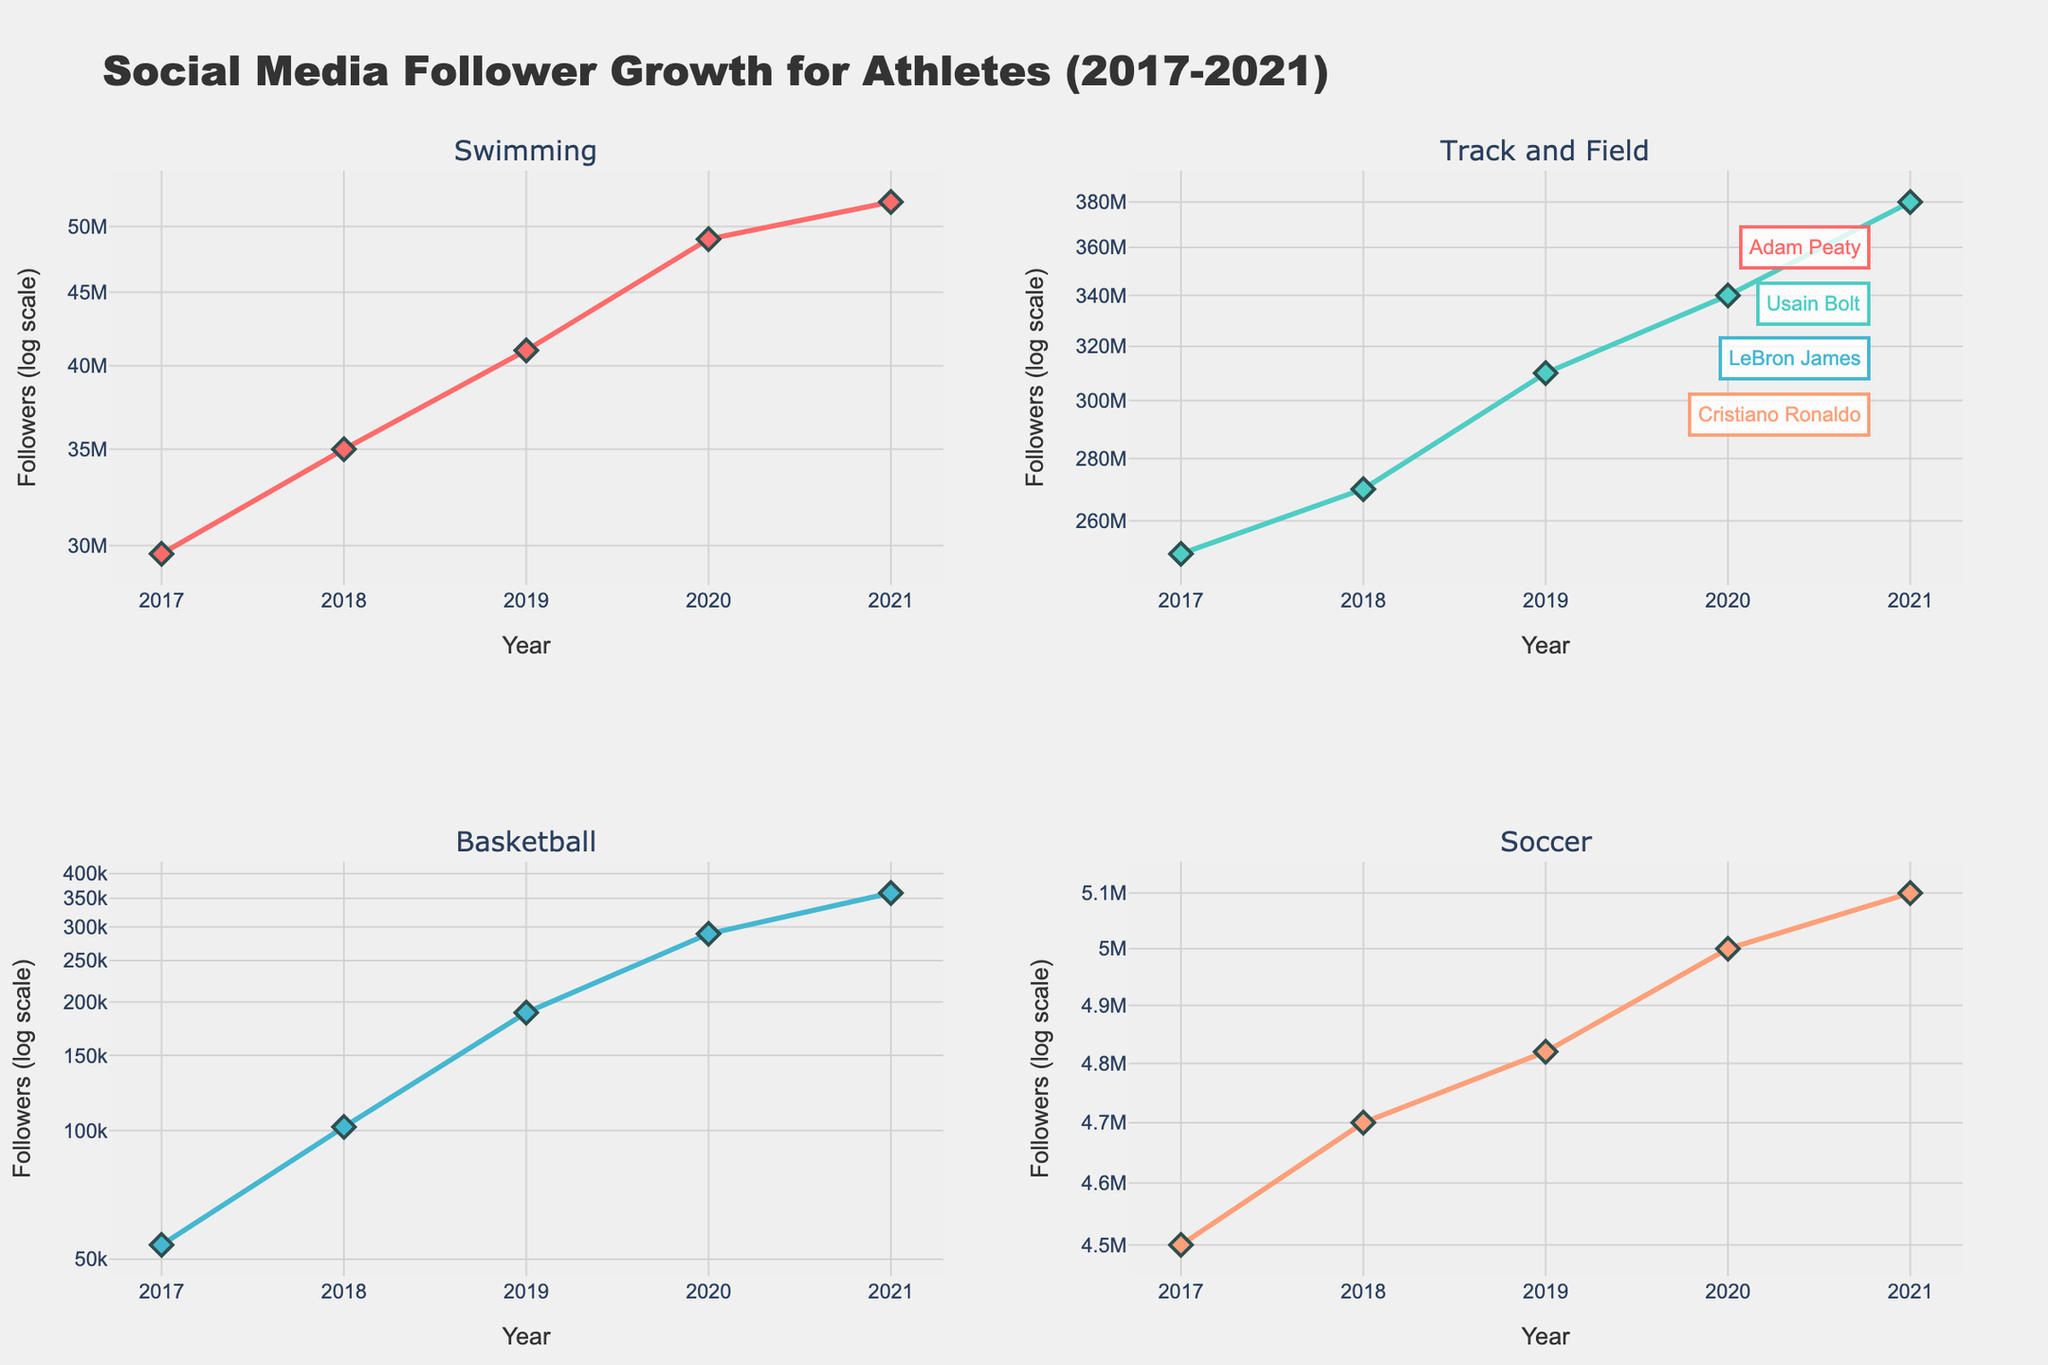What's the title of the figure? The title of the figure is displayed at the top and reads "Social Media Follower Growth for Athletes (2017-2021)."
Answer: Social Media Follower Growth for Athletes (2017-2021) How are the subplots organized in relation to the sporting events? The subplots are organized in a 2x2 grid, each representing a different sporting event: Swimming, Track and Field, Basketball, and Soccer.
Answer: 2x2 grid Which athlete had the highest number of followers in 2021? From the subplot with the highest number of followers, we can see Cristiano Ronaldo in Soccer had the most followers in 2021, at 380,000,000.
Answer: Cristiano Ronaldo Which subplot has the steepest growth in followers from 2017 to 2021? By comparing the slopes of the lines in each subplot, the subplot for Soccer (Cristiano Ronaldo) shows the steepest growth in followers between 2017 and 2021.
Answer: Soccer (Cristiano Ronaldo) Compare the follower growth of Adam Peaty and Usain Bolt between 2018 and 2019. Who had a higher percentage increase? Adam Peaty's followers increased from 102,000 to 189,000, a percentage increase of (189,000 - 102,000) / 102,000 * 100 ≈ 85.3%. Usain Bolt's followers increased from 4,700,000 to 4,820,000, a percentage increase of (4,820,000 - 4,700,000) / 4,700,000 * 100 ≈ 2.6%. Adam Peaty had a higher percentage increase.
Answer: Adam Peaty What is the unique aspect of the y-axes in these subplots? The y-axes of the subplots are on a logarithmic scale, which means equal distances on the axis represent equal multiplicative changes in follower count.
Answer: Logarithmic scale What was LeBron James's follower count in 2019 and how much did it increase by 2021? LeBron James had 41,000,000 followers in 2019, which increased to 52,000,000 in 2021. The increase is 52,000,000 - 41,000,000 = 11,000,000.
Answer: 11,000,000 Calculate the total number of followers Adam Peaty and Usain Bolt had in 2021 combined. Adam Peaty had 360,000 followers in 2021 and Usain Bolt had 5,100,000 followers. The combined total is 360,000 + 5,100,000 = 5,460,000.
Answer: 5,460,000 Which athlete showed the least growth in followers over the period from 2017 to 2021? By examining the plots, Usain Bolt in Track and Field showed the least growth in followers, with a relatively small increase compared to the other athletes.
Answer: Usain Bolt 